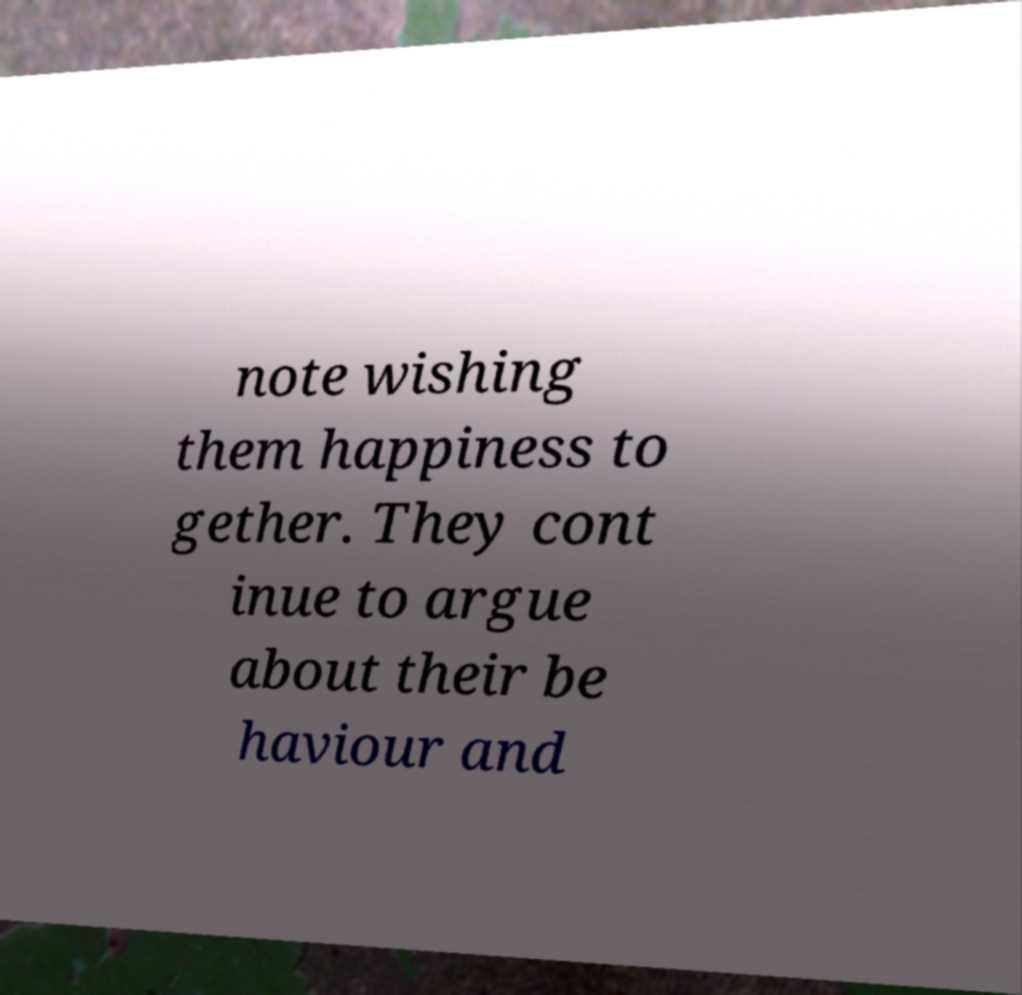Please read and relay the text visible in this image. What does it say? note wishing them happiness to gether. They cont inue to argue about their be haviour and 